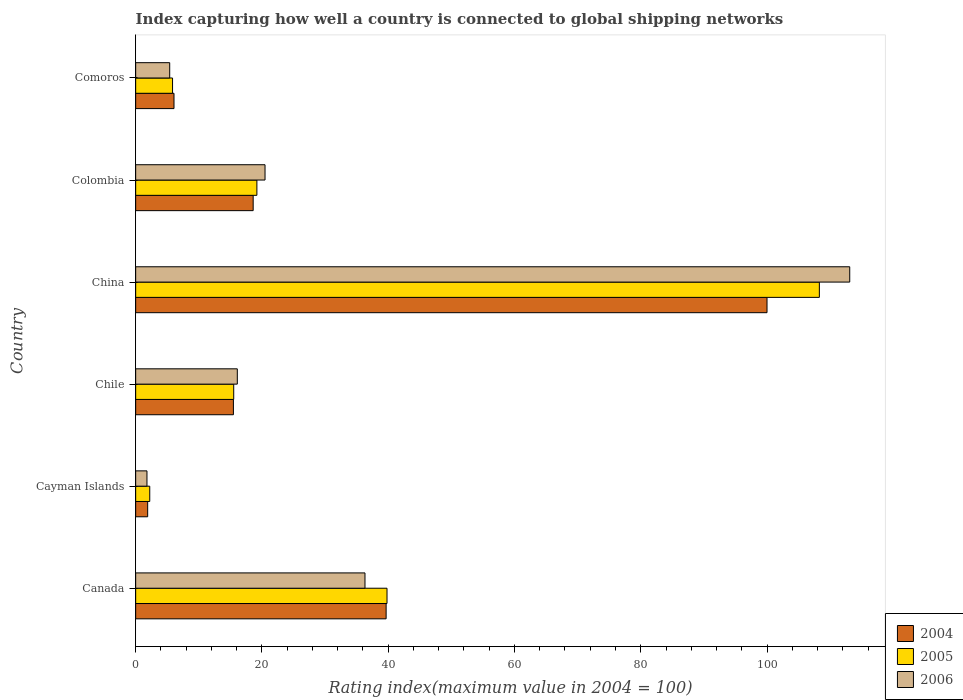How many different coloured bars are there?
Provide a short and direct response. 3. Are the number of bars per tick equal to the number of legend labels?
Provide a succinct answer. Yes. How many bars are there on the 5th tick from the bottom?
Provide a short and direct response. 3. What is the label of the 3rd group of bars from the top?
Ensure brevity in your answer.  China. In how many cases, is the number of bars for a given country not equal to the number of legend labels?
Your response must be concise. 0. What is the rating index in 2006 in Comoros?
Ensure brevity in your answer.  5.39. Across all countries, what is the maximum rating index in 2005?
Ensure brevity in your answer.  108.29. Across all countries, what is the minimum rating index in 2004?
Ensure brevity in your answer.  1.9. In which country was the rating index in 2004 maximum?
Keep it short and to the point. China. In which country was the rating index in 2006 minimum?
Ensure brevity in your answer.  Cayman Islands. What is the total rating index in 2005 in the graph?
Provide a short and direct response. 190.9. What is the difference between the rating index in 2006 in Chile and that in Colombia?
Ensure brevity in your answer.  -4.39. What is the difference between the rating index in 2006 in China and the rating index in 2005 in Cayman Islands?
Offer a very short reply. 110.87. What is the average rating index in 2004 per country?
Make the answer very short. 30.29. What is the difference between the rating index in 2004 and rating index in 2006 in Colombia?
Provide a succinct answer. -1.88. What is the ratio of the rating index in 2006 in Chile to that in Colombia?
Keep it short and to the point. 0.79. What is the difference between the highest and the second highest rating index in 2004?
Offer a terse response. 60.33. What is the difference between the highest and the lowest rating index in 2004?
Ensure brevity in your answer.  98.1. What does the 2nd bar from the bottom in Cayman Islands represents?
Your response must be concise. 2005. Is it the case that in every country, the sum of the rating index in 2005 and rating index in 2006 is greater than the rating index in 2004?
Your response must be concise. Yes. How many bars are there?
Your answer should be very brief. 18. Are all the bars in the graph horizontal?
Offer a terse response. Yes. What is the difference between two consecutive major ticks on the X-axis?
Your response must be concise. 20. Are the values on the major ticks of X-axis written in scientific E-notation?
Your answer should be very brief. No. Does the graph contain any zero values?
Your answer should be very brief. No. How many legend labels are there?
Ensure brevity in your answer.  3. How are the legend labels stacked?
Ensure brevity in your answer.  Vertical. What is the title of the graph?
Ensure brevity in your answer.  Index capturing how well a country is connected to global shipping networks. What is the label or title of the X-axis?
Offer a terse response. Rating index(maximum value in 2004 = 100). What is the Rating index(maximum value in 2004 = 100) of 2004 in Canada?
Your response must be concise. 39.67. What is the Rating index(maximum value in 2004 = 100) of 2005 in Canada?
Give a very brief answer. 39.81. What is the Rating index(maximum value in 2004 = 100) in 2006 in Canada?
Provide a short and direct response. 36.32. What is the Rating index(maximum value in 2004 = 100) in 2005 in Cayman Islands?
Provide a succinct answer. 2.23. What is the Rating index(maximum value in 2004 = 100) of 2006 in Cayman Islands?
Provide a short and direct response. 1.79. What is the Rating index(maximum value in 2004 = 100) of 2004 in Chile?
Keep it short and to the point. 15.48. What is the Rating index(maximum value in 2004 = 100) of 2005 in Chile?
Make the answer very short. 15.53. What is the Rating index(maximum value in 2004 = 100) in 2006 in Chile?
Give a very brief answer. 16.1. What is the Rating index(maximum value in 2004 = 100) of 2004 in China?
Give a very brief answer. 100. What is the Rating index(maximum value in 2004 = 100) in 2005 in China?
Provide a succinct answer. 108.29. What is the Rating index(maximum value in 2004 = 100) in 2006 in China?
Offer a very short reply. 113.1. What is the Rating index(maximum value in 2004 = 100) of 2004 in Colombia?
Keep it short and to the point. 18.61. What is the Rating index(maximum value in 2004 = 100) of 2005 in Colombia?
Keep it short and to the point. 19.2. What is the Rating index(maximum value in 2004 = 100) in 2006 in Colombia?
Make the answer very short. 20.49. What is the Rating index(maximum value in 2004 = 100) of 2004 in Comoros?
Provide a short and direct response. 6.07. What is the Rating index(maximum value in 2004 = 100) in 2005 in Comoros?
Ensure brevity in your answer.  5.84. What is the Rating index(maximum value in 2004 = 100) in 2006 in Comoros?
Offer a very short reply. 5.39. Across all countries, what is the maximum Rating index(maximum value in 2004 = 100) in 2004?
Give a very brief answer. 100. Across all countries, what is the maximum Rating index(maximum value in 2004 = 100) of 2005?
Ensure brevity in your answer.  108.29. Across all countries, what is the maximum Rating index(maximum value in 2004 = 100) in 2006?
Provide a succinct answer. 113.1. Across all countries, what is the minimum Rating index(maximum value in 2004 = 100) in 2005?
Provide a succinct answer. 2.23. Across all countries, what is the minimum Rating index(maximum value in 2004 = 100) of 2006?
Ensure brevity in your answer.  1.79. What is the total Rating index(maximum value in 2004 = 100) of 2004 in the graph?
Give a very brief answer. 181.73. What is the total Rating index(maximum value in 2004 = 100) of 2005 in the graph?
Provide a succinct answer. 190.9. What is the total Rating index(maximum value in 2004 = 100) in 2006 in the graph?
Your response must be concise. 193.19. What is the difference between the Rating index(maximum value in 2004 = 100) of 2004 in Canada and that in Cayman Islands?
Provide a succinct answer. 37.77. What is the difference between the Rating index(maximum value in 2004 = 100) in 2005 in Canada and that in Cayman Islands?
Your response must be concise. 37.58. What is the difference between the Rating index(maximum value in 2004 = 100) in 2006 in Canada and that in Cayman Islands?
Your answer should be very brief. 34.53. What is the difference between the Rating index(maximum value in 2004 = 100) in 2004 in Canada and that in Chile?
Offer a terse response. 24.19. What is the difference between the Rating index(maximum value in 2004 = 100) in 2005 in Canada and that in Chile?
Offer a very short reply. 24.28. What is the difference between the Rating index(maximum value in 2004 = 100) of 2006 in Canada and that in Chile?
Give a very brief answer. 20.22. What is the difference between the Rating index(maximum value in 2004 = 100) in 2004 in Canada and that in China?
Give a very brief answer. -60.33. What is the difference between the Rating index(maximum value in 2004 = 100) of 2005 in Canada and that in China?
Your answer should be compact. -68.48. What is the difference between the Rating index(maximum value in 2004 = 100) of 2006 in Canada and that in China?
Offer a very short reply. -76.78. What is the difference between the Rating index(maximum value in 2004 = 100) of 2004 in Canada and that in Colombia?
Provide a short and direct response. 21.06. What is the difference between the Rating index(maximum value in 2004 = 100) in 2005 in Canada and that in Colombia?
Give a very brief answer. 20.61. What is the difference between the Rating index(maximum value in 2004 = 100) in 2006 in Canada and that in Colombia?
Offer a terse response. 15.83. What is the difference between the Rating index(maximum value in 2004 = 100) of 2004 in Canada and that in Comoros?
Your response must be concise. 33.6. What is the difference between the Rating index(maximum value in 2004 = 100) of 2005 in Canada and that in Comoros?
Keep it short and to the point. 33.97. What is the difference between the Rating index(maximum value in 2004 = 100) in 2006 in Canada and that in Comoros?
Ensure brevity in your answer.  30.93. What is the difference between the Rating index(maximum value in 2004 = 100) of 2004 in Cayman Islands and that in Chile?
Make the answer very short. -13.58. What is the difference between the Rating index(maximum value in 2004 = 100) of 2006 in Cayman Islands and that in Chile?
Make the answer very short. -14.31. What is the difference between the Rating index(maximum value in 2004 = 100) in 2004 in Cayman Islands and that in China?
Keep it short and to the point. -98.1. What is the difference between the Rating index(maximum value in 2004 = 100) in 2005 in Cayman Islands and that in China?
Provide a short and direct response. -106.06. What is the difference between the Rating index(maximum value in 2004 = 100) in 2006 in Cayman Islands and that in China?
Keep it short and to the point. -111.31. What is the difference between the Rating index(maximum value in 2004 = 100) of 2004 in Cayman Islands and that in Colombia?
Your response must be concise. -16.71. What is the difference between the Rating index(maximum value in 2004 = 100) in 2005 in Cayman Islands and that in Colombia?
Offer a very short reply. -16.97. What is the difference between the Rating index(maximum value in 2004 = 100) in 2006 in Cayman Islands and that in Colombia?
Provide a short and direct response. -18.7. What is the difference between the Rating index(maximum value in 2004 = 100) in 2004 in Cayman Islands and that in Comoros?
Give a very brief answer. -4.17. What is the difference between the Rating index(maximum value in 2004 = 100) of 2005 in Cayman Islands and that in Comoros?
Give a very brief answer. -3.61. What is the difference between the Rating index(maximum value in 2004 = 100) of 2004 in Chile and that in China?
Give a very brief answer. -84.52. What is the difference between the Rating index(maximum value in 2004 = 100) of 2005 in Chile and that in China?
Give a very brief answer. -92.76. What is the difference between the Rating index(maximum value in 2004 = 100) in 2006 in Chile and that in China?
Offer a very short reply. -97. What is the difference between the Rating index(maximum value in 2004 = 100) of 2004 in Chile and that in Colombia?
Provide a succinct answer. -3.13. What is the difference between the Rating index(maximum value in 2004 = 100) of 2005 in Chile and that in Colombia?
Offer a very short reply. -3.67. What is the difference between the Rating index(maximum value in 2004 = 100) of 2006 in Chile and that in Colombia?
Your answer should be compact. -4.39. What is the difference between the Rating index(maximum value in 2004 = 100) of 2004 in Chile and that in Comoros?
Ensure brevity in your answer.  9.41. What is the difference between the Rating index(maximum value in 2004 = 100) of 2005 in Chile and that in Comoros?
Ensure brevity in your answer.  9.69. What is the difference between the Rating index(maximum value in 2004 = 100) of 2006 in Chile and that in Comoros?
Offer a very short reply. 10.71. What is the difference between the Rating index(maximum value in 2004 = 100) in 2004 in China and that in Colombia?
Your answer should be compact. 81.39. What is the difference between the Rating index(maximum value in 2004 = 100) in 2005 in China and that in Colombia?
Give a very brief answer. 89.09. What is the difference between the Rating index(maximum value in 2004 = 100) of 2006 in China and that in Colombia?
Provide a short and direct response. 92.61. What is the difference between the Rating index(maximum value in 2004 = 100) of 2004 in China and that in Comoros?
Your answer should be compact. 93.93. What is the difference between the Rating index(maximum value in 2004 = 100) of 2005 in China and that in Comoros?
Offer a terse response. 102.45. What is the difference between the Rating index(maximum value in 2004 = 100) in 2006 in China and that in Comoros?
Your answer should be compact. 107.71. What is the difference between the Rating index(maximum value in 2004 = 100) of 2004 in Colombia and that in Comoros?
Offer a very short reply. 12.54. What is the difference between the Rating index(maximum value in 2004 = 100) of 2005 in Colombia and that in Comoros?
Your response must be concise. 13.36. What is the difference between the Rating index(maximum value in 2004 = 100) of 2006 in Colombia and that in Comoros?
Your answer should be compact. 15.1. What is the difference between the Rating index(maximum value in 2004 = 100) of 2004 in Canada and the Rating index(maximum value in 2004 = 100) of 2005 in Cayman Islands?
Offer a very short reply. 37.44. What is the difference between the Rating index(maximum value in 2004 = 100) of 2004 in Canada and the Rating index(maximum value in 2004 = 100) of 2006 in Cayman Islands?
Your answer should be compact. 37.88. What is the difference between the Rating index(maximum value in 2004 = 100) in 2005 in Canada and the Rating index(maximum value in 2004 = 100) in 2006 in Cayman Islands?
Ensure brevity in your answer.  38.02. What is the difference between the Rating index(maximum value in 2004 = 100) of 2004 in Canada and the Rating index(maximum value in 2004 = 100) of 2005 in Chile?
Offer a very short reply. 24.14. What is the difference between the Rating index(maximum value in 2004 = 100) in 2004 in Canada and the Rating index(maximum value in 2004 = 100) in 2006 in Chile?
Provide a short and direct response. 23.57. What is the difference between the Rating index(maximum value in 2004 = 100) of 2005 in Canada and the Rating index(maximum value in 2004 = 100) of 2006 in Chile?
Provide a short and direct response. 23.71. What is the difference between the Rating index(maximum value in 2004 = 100) of 2004 in Canada and the Rating index(maximum value in 2004 = 100) of 2005 in China?
Offer a very short reply. -68.62. What is the difference between the Rating index(maximum value in 2004 = 100) of 2004 in Canada and the Rating index(maximum value in 2004 = 100) of 2006 in China?
Make the answer very short. -73.43. What is the difference between the Rating index(maximum value in 2004 = 100) in 2005 in Canada and the Rating index(maximum value in 2004 = 100) in 2006 in China?
Provide a succinct answer. -73.29. What is the difference between the Rating index(maximum value in 2004 = 100) of 2004 in Canada and the Rating index(maximum value in 2004 = 100) of 2005 in Colombia?
Offer a very short reply. 20.47. What is the difference between the Rating index(maximum value in 2004 = 100) in 2004 in Canada and the Rating index(maximum value in 2004 = 100) in 2006 in Colombia?
Keep it short and to the point. 19.18. What is the difference between the Rating index(maximum value in 2004 = 100) of 2005 in Canada and the Rating index(maximum value in 2004 = 100) of 2006 in Colombia?
Offer a very short reply. 19.32. What is the difference between the Rating index(maximum value in 2004 = 100) in 2004 in Canada and the Rating index(maximum value in 2004 = 100) in 2005 in Comoros?
Give a very brief answer. 33.83. What is the difference between the Rating index(maximum value in 2004 = 100) of 2004 in Canada and the Rating index(maximum value in 2004 = 100) of 2006 in Comoros?
Make the answer very short. 34.28. What is the difference between the Rating index(maximum value in 2004 = 100) in 2005 in Canada and the Rating index(maximum value in 2004 = 100) in 2006 in Comoros?
Make the answer very short. 34.42. What is the difference between the Rating index(maximum value in 2004 = 100) in 2004 in Cayman Islands and the Rating index(maximum value in 2004 = 100) in 2005 in Chile?
Ensure brevity in your answer.  -13.63. What is the difference between the Rating index(maximum value in 2004 = 100) in 2004 in Cayman Islands and the Rating index(maximum value in 2004 = 100) in 2006 in Chile?
Keep it short and to the point. -14.2. What is the difference between the Rating index(maximum value in 2004 = 100) in 2005 in Cayman Islands and the Rating index(maximum value in 2004 = 100) in 2006 in Chile?
Ensure brevity in your answer.  -13.87. What is the difference between the Rating index(maximum value in 2004 = 100) of 2004 in Cayman Islands and the Rating index(maximum value in 2004 = 100) of 2005 in China?
Ensure brevity in your answer.  -106.39. What is the difference between the Rating index(maximum value in 2004 = 100) of 2004 in Cayman Islands and the Rating index(maximum value in 2004 = 100) of 2006 in China?
Make the answer very short. -111.2. What is the difference between the Rating index(maximum value in 2004 = 100) in 2005 in Cayman Islands and the Rating index(maximum value in 2004 = 100) in 2006 in China?
Your response must be concise. -110.87. What is the difference between the Rating index(maximum value in 2004 = 100) in 2004 in Cayman Islands and the Rating index(maximum value in 2004 = 100) in 2005 in Colombia?
Your response must be concise. -17.3. What is the difference between the Rating index(maximum value in 2004 = 100) in 2004 in Cayman Islands and the Rating index(maximum value in 2004 = 100) in 2006 in Colombia?
Provide a short and direct response. -18.59. What is the difference between the Rating index(maximum value in 2004 = 100) in 2005 in Cayman Islands and the Rating index(maximum value in 2004 = 100) in 2006 in Colombia?
Offer a terse response. -18.26. What is the difference between the Rating index(maximum value in 2004 = 100) in 2004 in Cayman Islands and the Rating index(maximum value in 2004 = 100) in 2005 in Comoros?
Keep it short and to the point. -3.94. What is the difference between the Rating index(maximum value in 2004 = 100) in 2004 in Cayman Islands and the Rating index(maximum value in 2004 = 100) in 2006 in Comoros?
Your answer should be very brief. -3.49. What is the difference between the Rating index(maximum value in 2004 = 100) in 2005 in Cayman Islands and the Rating index(maximum value in 2004 = 100) in 2006 in Comoros?
Keep it short and to the point. -3.16. What is the difference between the Rating index(maximum value in 2004 = 100) of 2004 in Chile and the Rating index(maximum value in 2004 = 100) of 2005 in China?
Offer a very short reply. -92.81. What is the difference between the Rating index(maximum value in 2004 = 100) of 2004 in Chile and the Rating index(maximum value in 2004 = 100) of 2006 in China?
Keep it short and to the point. -97.62. What is the difference between the Rating index(maximum value in 2004 = 100) in 2005 in Chile and the Rating index(maximum value in 2004 = 100) in 2006 in China?
Your answer should be very brief. -97.57. What is the difference between the Rating index(maximum value in 2004 = 100) of 2004 in Chile and the Rating index(maximum value in 2004 = 100) of 2005 in Colombia?
Your answer should be compact. -3.72. What is the difference between the Rating index(maximum value in 2004 = 100) in 2004 in Chile and the Rating index(maximum value in 2004 = 100) in 2006 in Colombia?
Offer a very short reply. -5.01. What is the difference between the Rating index(maximum value in 2004 = 100) in 2005 in Chile and the Rating index(maximum value in 2004 = 100) in 2006 in Colombia?
Your answer should be very brief. -4.96. What is the difference between the Rating index(maximum value in 2004 = 100) in 2004 in Chile and the Rating index(maximum value in 2004 = 100) in 2005 in Comoros?
Ensure brevity in your answer.  9.64. What is the difference between the Rating index(maximum value in 2004 = 100) of 2004 in Chile and the Rating index(maximum value in 2004 = 100) of 2006 in Comoros?
Offer a terse response. 10.09. What is the difference between the Rating index(maximum value in 2004 = 100) of 2005 in Chile and the Rating index(maximum value in 2004 = 100) of 2006 in Comoros?
Make the answer very short. 10.14. What is the difference between the Rating index(maximum value in 2004 = 100) of 2004 in China and the Rating index(maximum value in 2004 = 100) of 2005 in Colombia?
Keep it short and to the point. 80.8. What is the difference between the Rating index(maximum value in 2004 = 100) in 2004 in China and the Rating index(maximum value in 2004 = 100) in 2006 in Colombia?
Ensure brevity in your answer.  79.51. What is the difference between the Rating index(maximum value in 2004 = 100) in 2005 in China and the Rating index(maximum value in 2004 = 100) in 2006 in Colombia?
Make the answer very short. 87.8. What is the difference between the Rating index(maximum value in 2004 = 100) of 2004 in China and the Rating index(maximum value in 2004 = 100) of 2005 in Comoros?
Provide a short and direct response. 94.16. What is the difference between the Rating index(maximum value in 2004 = 100) in 2004 in China and the Rating index(maximum value in 2004 = 100) in 2006 in Comoros?
Your answer should be compact. 94.61. What is the difference between the Rating index(maximum value in 2004 = 100) of 2005 in China and the Rating index(maximum value in 2004 = 100) of 2006 in Comoros?
Provide a succinct answer. 102.9. What is the difference between the Rating index(maximum value in 2004 = 100) of 2004 in Colombia and the Rating index(maximum value in 2004 = 100) of 2005 in Comoros?
Ensure brevity in your answer.  12.77. What is the difference between the Rating index(maximum value in 2004 = 100) of 2004 in Colombia and the Rating index(maximum value in 2004 = 100) of 2006 in Comoros?
Offer a very short reply. 13.22. What is the difference between the Rating index(maximum value in 2004 = 100) of 2005 in Colombia and the Rating index(maximum value in 2004 = 100) of 2006 in Comoros?
Keep it short and to the point. 13.81. What is the average Rating index(maximum value in 2004 = 100) in 2004 per country?
Your answer should be compact. 30.29. What is the average Rating index(maximum value in 2004 = 100) in 2005 per country?
Your answer should be compact. 31.82. What is the average Rating index(maximum value in 2004 = 100) in 2006 per country?
Provide a succinct answer. 32.2. What is the difference between the Rating index(maximum value in 2004 = 100) of 2004 and Rating index(maximum value in 2004 = 100) of 2005 in Canada?
Provide a succinct answer. -0.14. What is the difference between the Rating index(maximum value in 2004 = 100) in 2004 and Rating index(maximum value in 2004 = 100) in 2006 in Canada?
Provide a succinct answer. 3.35. What is the difference between the Rating index(maximum value in 2004 = 100) of 2005 and Rating index(maximum value in 2004 = 100) of 2006 in Canada?
Provide a short and direct response. 3.49. What is the difference between the Rating index(maximum value in 2004 = 100) of 2004 and Rating index(maximum value in 2004 = 100) of 2005 in Cayman Islands?
Provide a short and direct response. -0.33. What is the difference between the Rating index(maximum value in 2004 = 100) in 2004 and Rating index(maximum value in 2004 = 100) in 2006 in Cayman Islands?
Give a very brief answer. 0.11. What is the difference between the Rating index(maximum value in 2004 = 100) of 2005 and Rating index(maximum value in 2004 = 100) of 2006 in Cayman Islands?
Your answer should be compact. 0.44. What is the difference between the Rating index(maximum value in 2004 = 100) of 2004 and Rating index(maximum value in 2004 = 100) of 2006 in Chile?
Your response must be concise. -0.62. What is the difference between the Rating index(maximum value in 2004 = 100) of 2005 and Rating index(maximum value in 2004 = 100) of 2006 in Chile?
Your answer should be very brief. -0.57. What is the difference between the Rating index(maximum value in 2004 = 100) in 2004 and Rating index(maximum value in 2004 = 100) in 2005 in China?
Give a very brief answer. -8.29. What is the difference between the Rating index(maximum value in 2004 = 100) of 2005 and Rating index(maximum value in 2004 = 100) of 2006 in China?
Offer a very short reply. -4.81. What is the difference between the Rating index(maximum value in 2004 = 100) of 2004 and Rating index(maximum value in 2004 = 100) of 2005 in Colombia?
Give a very brief answer. -0.59. What is the difference between the Rating index(maximum value in 2004 = 100) in 2004 and Rating index(maximum value in 2004 = 100) in 2006 in Colombia?
Offer a very short reply. -1.88. What is the difference between the Rating index(maximum value in 2004 = 100) in 2005 and Rating index(maximum value in 2004 = 100) in 2006 in Colombia?
Give a very brief answer. -1.29. What is the difference between the Rating index(maximum value in 2004 = 100) of 2004 and Rating index(maximum value in 2004 = 100) of 2005 in Comoros?
Make the answer very short. 0.23. What is the difference between the Rating index(maximum value in 2004 = 100) in 2004 and Rating index(maximum value in 2004 = 100) in 2006 in Comoros?
Ensure brevity in your answer.  0.68. What is the difference between the Rating index(maximum value in 2004 = 100) of 2005 and Rating index(maximum value in 2004 = 100) of 2006 in Comoros?
Provide a succinct answer. 0.45. What is the ratio of the Rating index(maximum value in 2004 = 100) of 2004 in Canada to that in Cayman Islands?
Your answer should be very brief. 20.88. What is the ratio of the Rating index(maximum value in 2004 = 100) in 2005 in Canada to that in Cayman Islands?
Your answer should be compact. 17.85. What is the ratio of the Rating index(maximum value in 2004 = 100) of 2006 in Canada to that in Cayman Islands?
Keep it short and to the point. 20.29. What is the ratio of the Rating index(maximum value in 2004 = 100) of 2004 in Canada to that in Chile?
Offer a very short reply. 2.56. What is the ratio of the Rating index(maximum value in 2004 = 100) of 2005 in Canada to that in Chile?
Your answer should be very brief. 2.56. What is the ratio of the Rating index(maximum value in 2004 = 100) of 2006 in Canada to that in Chile?
Your answer should be very brief. 2.26. What is the ratio of the Rating index(maximum value in 2004 = 100) of 2004 in Canada to that in China?
Provide a succinct answer. 0.4. What is the ratio of the Rating index(maximum value in 2004 = 100) in 2005 in Canada to that in China?
Offer a terse response. 0.37. What is the ratio of the Rating index(maximum value in 2004 = 100) of 2006 in Canada to that in China?
Your answer should be very brief. 0.32. What is the ratio of the Rating index(maximum value in 2004 = 100) in 2004 in Canada to that in Colombia?
Your answer should be very brief. 2.13. What is the ratio of the Rating index(maximum value in 2004 = 100) in 2005 in Canada to that in Colombia?
Offer a very short reply. 2.07. What is the ratio of the Rating index(maximum value in 2004 = 100) of 2006 in Canada to that in Colombia?
Make the answer very short. 1.77. What is the ratio of the Rating index(maximum value in 2004 = 100) in 2004 in Canada to that in Comoros?
Provide a short and direct response. 6.54. What is the ratio of the Rating index(maximum value in 2004 = 100) in 2005 in Canada to that in Comoros?
Give a very brief answer. 6.82. What is the ratio of the Rating index(maximum value in 2004 = 100) of 2006 in Canada to that in Comoros?
Keep it short and to the point. 6.74. What is the ratio of the Rating index(maximum value in 2004 = 100) of 2004 in Cayman Islands to that in Chile?
Make the answer very short. 0.12. What is the ratio of the Rating index(maximum value in 2004 = 100) in 2005 in Cayman Islands to that in Chile?
Your answer should be compact. 0.14. What is the ratio of the Rating index(maximum value in 2004 = 100) in 2006 in Cayman Islands to that in Chile?
Your answer should be very brief. 0.11. What is the ratio of the Rating index(maximum value in 2004 = 100) of 2004 in Cayman Islands to that in China?
Provide a short and direct response. 0.02. What is the ratio of the Rating index(maximum value in 2004 = 100) in 2005 in Cayman Islands to that in China?
Ensure brevity in your answer.  0.02. What is the ratio of the Rating index(maximum value in 2004 = 100) of 2006 in Cayman Islands to that in China?
Give a very brief answer. 0.02. What is the ratio of the Rating index(maximum value in 2004 = 100) in 2004 in Cayman Islands to that in Colombia?
Ensure brevity in your answer.  0.1. What is the ratio of the Rating index(maximum value in 2004 = 100) of 2005 in Cayman Islands to that in Colombia?
Make the answer very short. 0.12. What is the ratio of the Rating index(maximum value in 2004 = 100) in 2006 in Cayman Islands to that in Colombia?
Provide a short and direct response. 0.09. What is the ratio of the Rating index(maximum value in 2004 = 100) of 2004 in Cayman Islands to that in Comoros?
Give a very brief answer. 0.31. What is the ratio of the Rating index(maximum value in 2004 = 100) in 2005 in Cayman Islands to that in Comoros?
Offer a very short reply. 0.38. What is the ratio of the Rating index(maximum value in 2004 = 100) of 2006 in Cayman Islands to that in Comoros?
Keep it short and to the point. 0.33. What is the ratio of the Rating index(maximum value in 2004 = 100) in 2004 in Chile to that in China?
Your answer should be compact. 0.15. What is the ratio of the Rating index(maximum value in 2004 = 100) of 2005 in Chile to that in China?
Your answer should be compact. 0.14. What is the ratio of the Rating index(maximum value in 2004 = 100) of 2006 in Chile to that in China?
Provide a succinct answer. 0.14. What is the ratio of the Rating index(maximum value in 2004 = 100) in 2004 in Chile to that in Colombia?
Your answer should be very brief. 0.83. What is the ratio of the Rating index(maximum value in 2004 = 100) in 2005 in Chile to that in Colombia?
Your answer should be very brief. 0.81. What is the ratio of the Rating index(maximum value in 2004 = 100) of 2006 in Chile to that in Colombia?
Keep it short and to the point. 0.79. What is the ratio of the Rating index(maximum value in 2004 = 100) of 2004 in Chile to that in Comoros?
Your response must be concise. 2.55. What is the ratio of the Rating index(maximum value in 2004 = 100) of 2005 in Chile to that in Comoros?
Offer a terse response. 2.66. What is the ratio of the Rating index(maximum value in 2004 = 100) in 2006 in Chile to that in Comoros?
Offer a very short reply. 2.99. What is the ratio of the Rating index(maximum value in 2004 = 100) in 2004 in China to that in Colombia?
Offer a very short reply. 5.37. What is the ratio of the Rating index(maximum value in 2004 = 100) in 2005 in China to that in Colombia?
Your answer should be very brief. 5.64. What is the ratio of the Rating index(maximum value in 2004 = 100) in 2006 in China to that in Colombia?
Offer a terse response. 5.52. What is the ratio of the Rating index(maximum value in 2004 = 100) in 2004 in China to that in Comoros?
Give a very brief answer. 16.47. What is the ratio of the Rating index(maximum value in 2004 = 100) of 2005 in China to that in Comoros?
Provide a succinct answer. 18.54. What is the ratio of the Rating index(maximum value in 2004 = 100) of 2006 in China to that in Comoros?
Give a very brief answer. 20.98. What is the ratio of the Rating index(maximum value in 2004 = 100) of 2004 in Colombia to that in Comoros?
Your answer should be compact. 3.07. What is the ratio of the Rating index(maximum value in 2004 = 100) in 2005 in Colombia to that in Comoros?
Your answer should be very brief. 3.29. What is the ratio of the Rating index(maximum value in 2004 = 100) in 2006 in Colombia to that in Comoros?
Your answer should be very brief. 3.8. What is the difference between the highest and the second highest Rating index(maximum value in 2004 = 100) of 2004?
Offer a terse response. 60.33. What is the difference between the highest and the second highest Rating index(maximum value in 2004 = 100) in 2005?
Your response must be concise. 68.48. What is the difference between the highest and the second highest Rating index(maximum value in 2004 = 100) in 2006?
Provide a succinct answer. 76.78. What is the difference between the highest and the lowest Rating index(maximum value in 2004 = 100) in 2004?
Your answer should be compact. 98.1. What is the difference between the highest and the lowest Rating index(maximum value in 2004 = 100) of 2005?
Offer a terse response. 106.06. What is the difference between the highest and the lowest Rating index(maximum value in 2004 = 100) of 2006?
Keep it short and to the point. 111.31. 